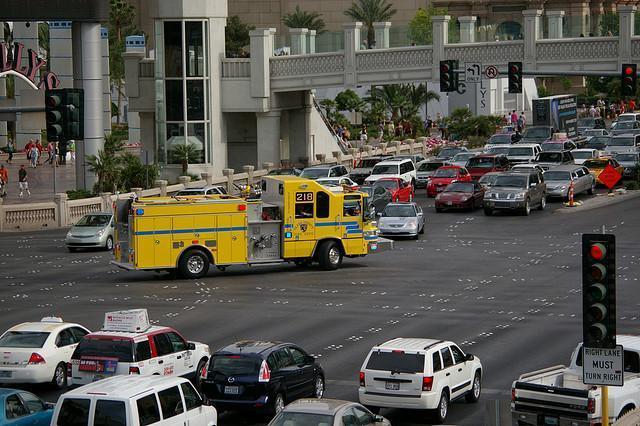How many trucks are there?
Give a very brief answer. 3. How many cars are in the photo?
Give a very brief answer. 8. 